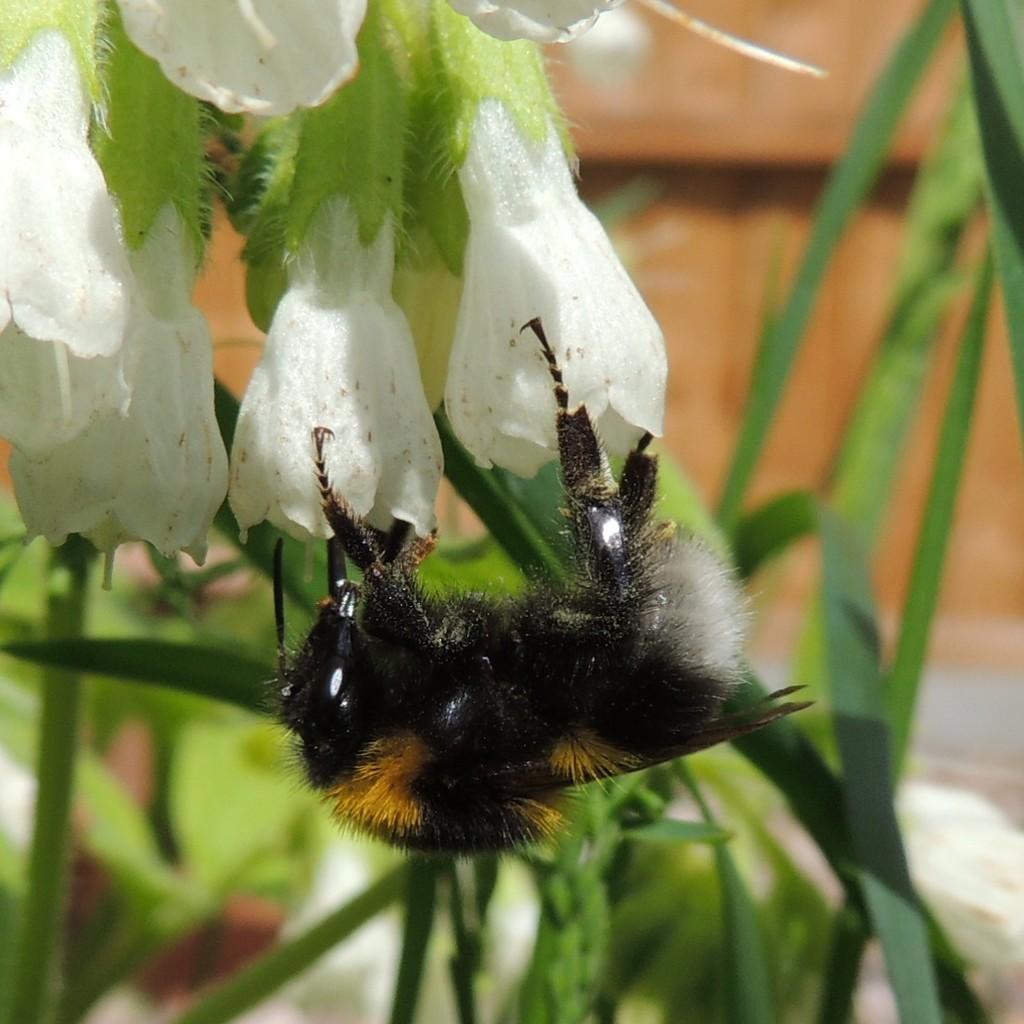Can you describe this image briefly? In this image we can see a black color insect in on the red color flowers. We can see the grass in the background. 